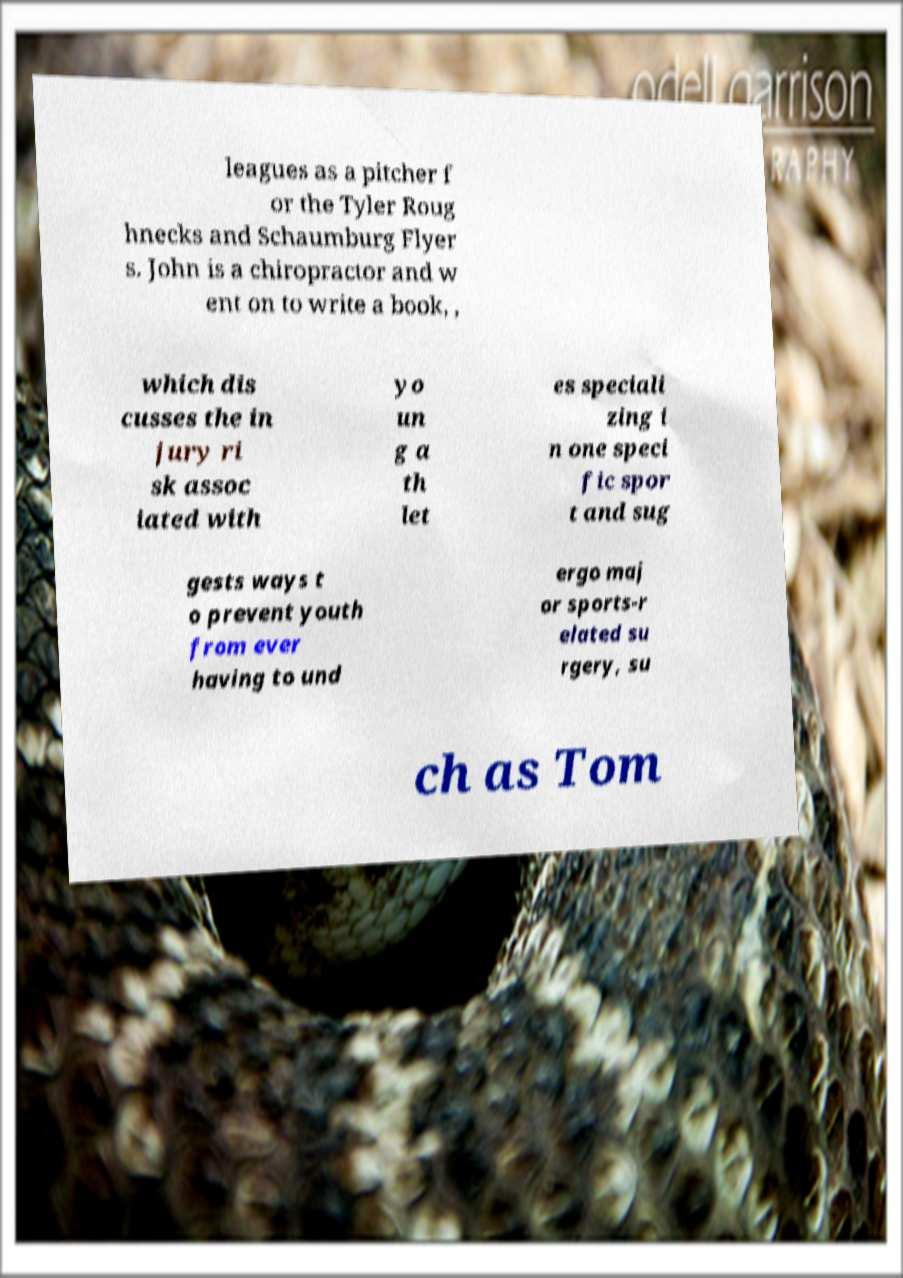Can you accurately transcribe the text from the provided image for me? leagues as a pitcher f or the Tyler Roug hnecks and Schaumburg Flyer s. John is a chiropractor and w ent on to write a book, , which dis cusses the in jury ri sk assoc iated with yo un g a th let es speciali zing i n one speci fic spor t and sug gests ways t o prevent youth from ever having to und ergo maj or sports-r elated su rgery, su ch as Tom 